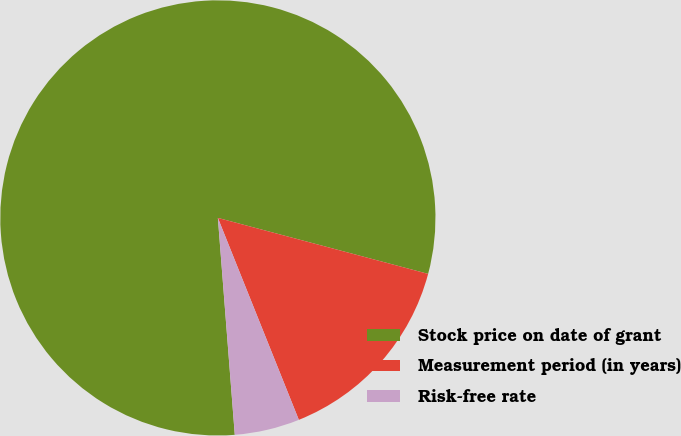<chart> <loc_0><loc_0><loc_500><loc_500><pie_chart><fcel>Stock price on date of grant<fcel>Measurement period (in years)<fcel>Risk-free rate<nl><fcel>80.38%<fcel>14.79%<fcel>4.83%<nl></chart> 